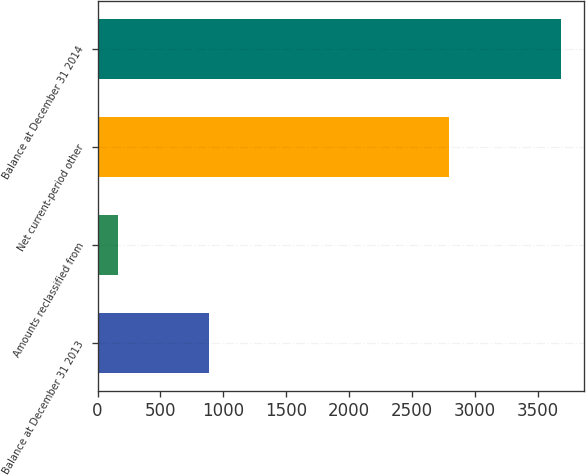Convert chart. <chart><loc_0><loc_0><loc_500><loc_500><bar_chart><fcel>Balance at December 31 2013<fcel>Amounts reclassified from<fcel>Net current-period other<fcel>Balance at December 31 2014<nl><fcel>887<fcel>163<fcel>2796<fcel>3683<nl></chart> 